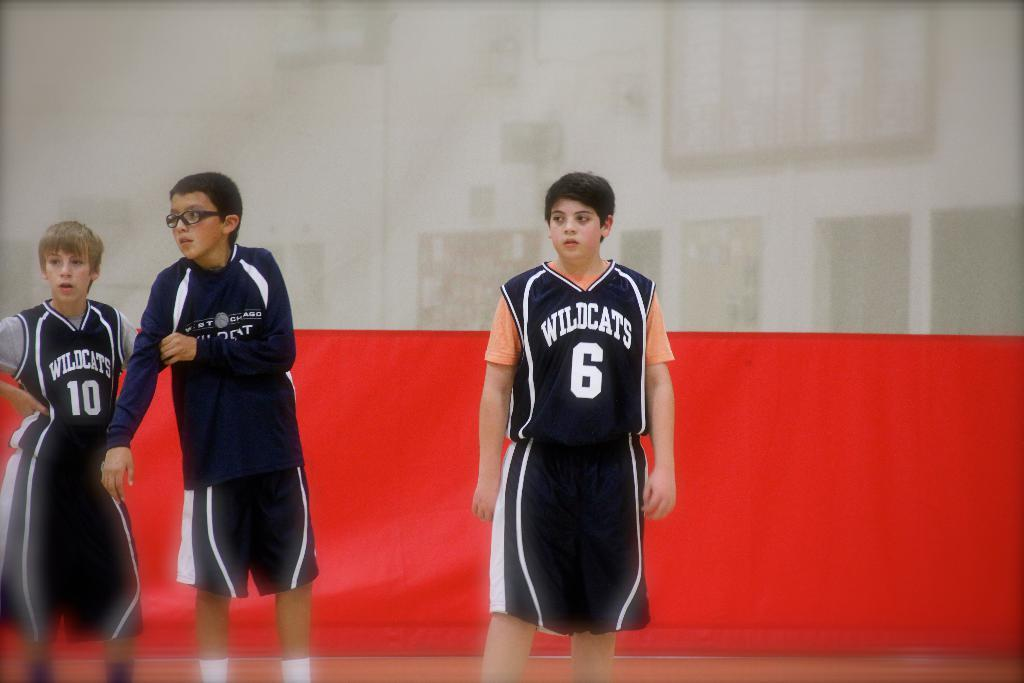<image>
Share a concise interpretation of the image provided. Basketball player wearing a Wildcats jersey watching something. 